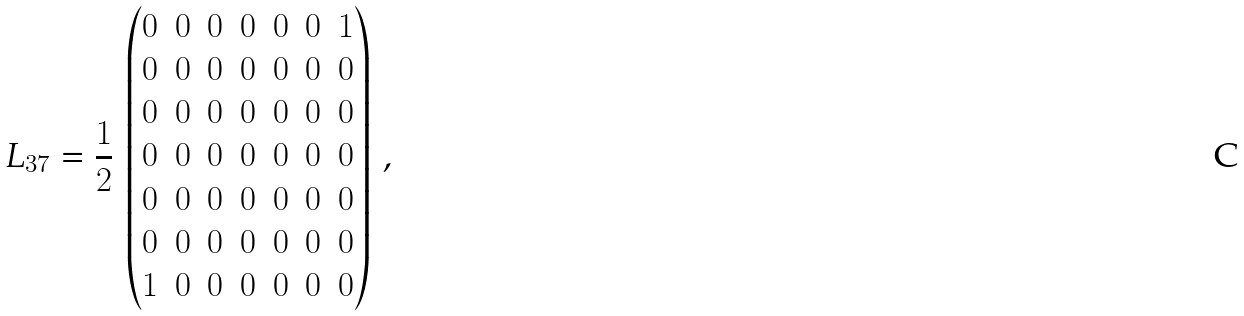Convert formula to latex. <formula><loc_0><loc_0><loc_500><loc_500>L _ { 3 7 } = \frac { 1 } { 2 } \, \begin{pmatrix} 0 & 0 & 0 & 0 & 0 & 0 & 1 \\ 0 & 0 & 0 & 0 & 0 & 0 & 0 \\ 0 & 0 & 0 & 0 & 0 & 0 & 0 \\ 0 & 0 & 0 & 0 & 0 & 0 & 0 \\ 0 & 0 & 0 & 0 & 0 & 0 & 0 \\ 0 & 0 & 0 & 0 & 0 & 0 & 0 \\ 1 & 0 & 0 & 0 & 0 & 0 & 0 \end{pmatrix} \, ,</formula> 